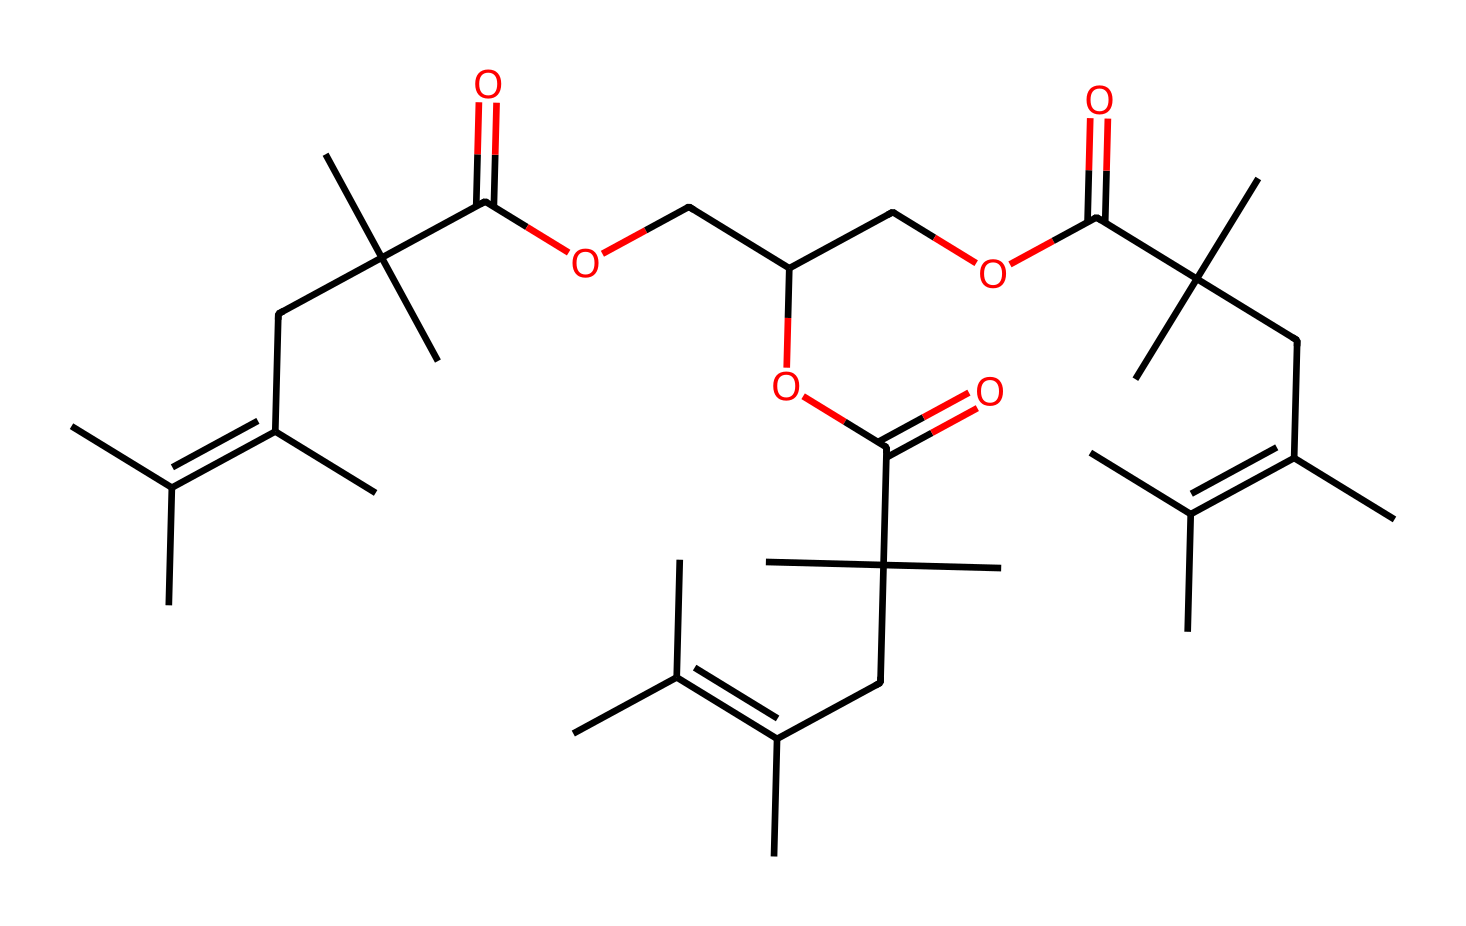how many carbon atoms are in this chemical structure? By breaking down the SMILES representation, we can count each carbon atom denoted by 'C'. Each segment shows multiple carbon atoms, and careful accounting gives us a total count.
Answer: 40 what is the highest degree of branching in the carbon backbone? To determine the highest degree of branching, I analyze the connections of carbon atoms (the 'C' atoms), particularly noting where tertiary or quaternary carbon atoms appear. In this case, the presence of multiple branches indicates a high degree of branching.
Answer: four does this compound contain any heteroatoms? Heteroatoms are atoms other than carbon and hydrogen, like oxygen, nitrogen, etc. Examining the SMILES structure clearly reveals the presence of 'O' (oxygen) in multiple places, confirming that the compound does contain heteroatoms.
Answer: yes what type of chemical structure does this compound represent? The presence of multiple branching and functional groups (specifically esters and carboxylic acids indicated by the occurrence of 'O' and '=O') identifies this compound as a synthetic rubber, commonly used in tires.
Answer: synthetic rubber is this compound likely to be soluble in water? Non-electrolytes like this compound typically have low solubility in water, especially given the hydrophobic nature of the polymer chains evident through the extensive carbon backbone and limited polar functional groups.
Answer: no 